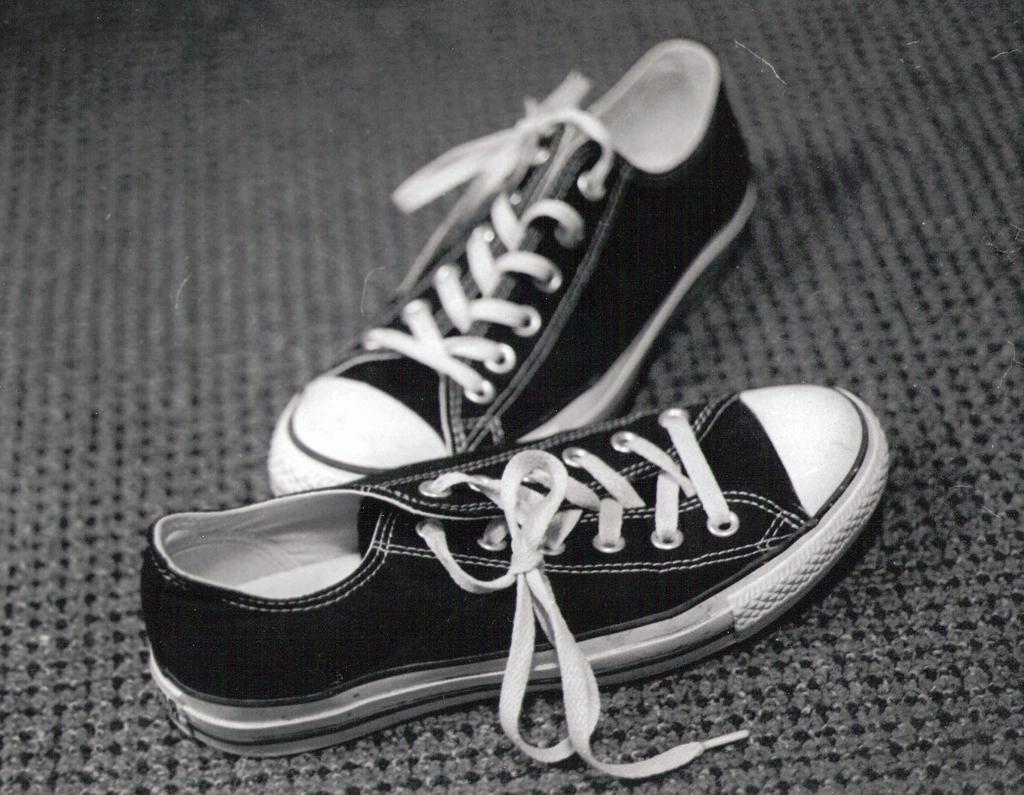What objects are placed on a mat in the image? There are shoes on a mat in the image. What is the color scheme of the image? The image is in black and white mode. How many girls are visible in the image? There are no girls present in the image; it only features shoes on a mat. Can you tell me the account number of the shoes in the image? There is no account number associated with the shoes in the image, as they are not a financial entity. 